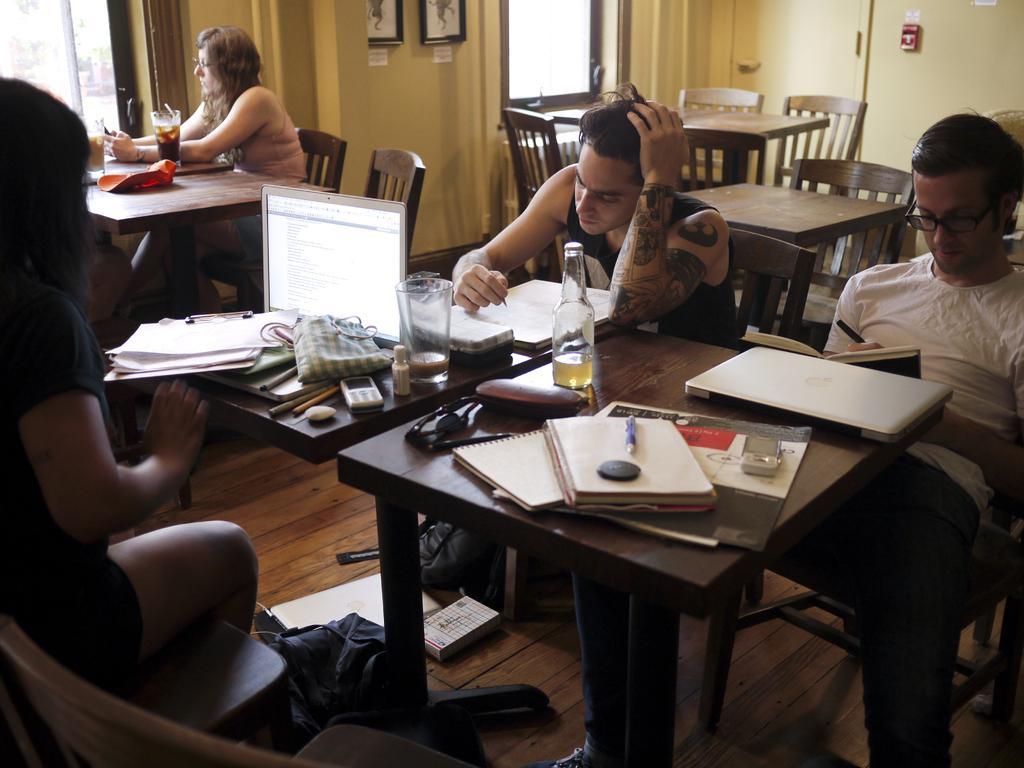How would you summarize this image in a sentence or two? Here we can see a group of people sitting on chairs with table in front of them having books, laptops, glasses and bottles on it and the wall we can see portraits present 